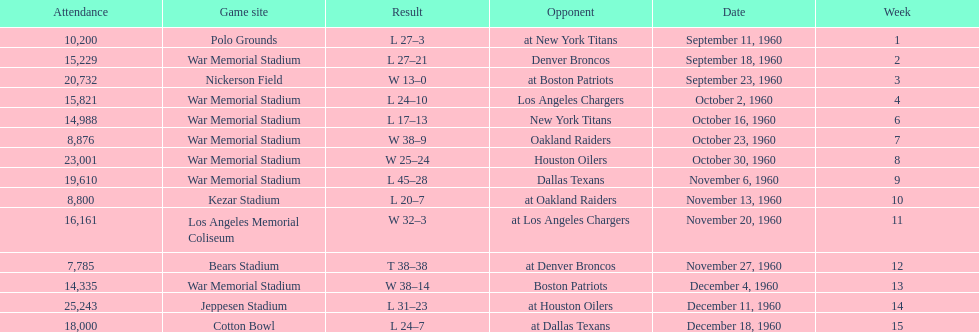What was the largest difference of points in a single game? 29. 